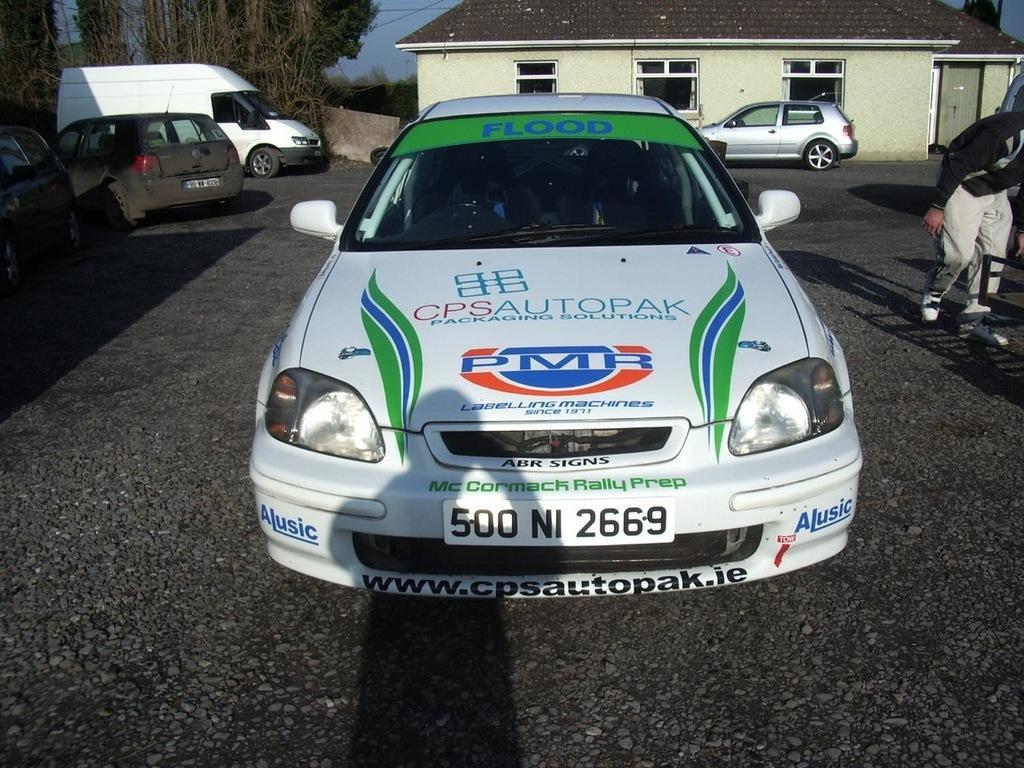Describe this image in one or two sentences. In this picture there are vehicles on the road. At the back there is a building and there are trees. On the right side of the image there is a person walking. At the top there is sky and there are wires. At the bottom there is a road. In the foreground there is a shadow of a person on the road and on the vehicle and there is text on the vehicle. 